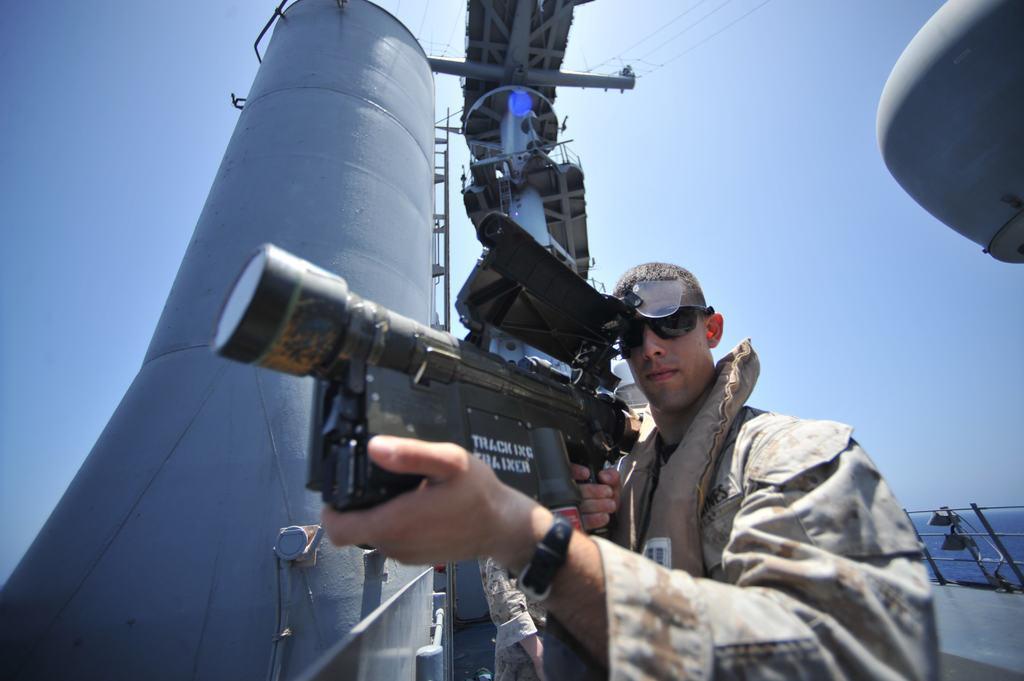Describe this image in one or two sentences. In this image in front there is a person holding the camera. Behind him there is a cylindrical shaped metal structure. In the background of the image there is a metal fence. There is water. At the top of the image there is sky. 